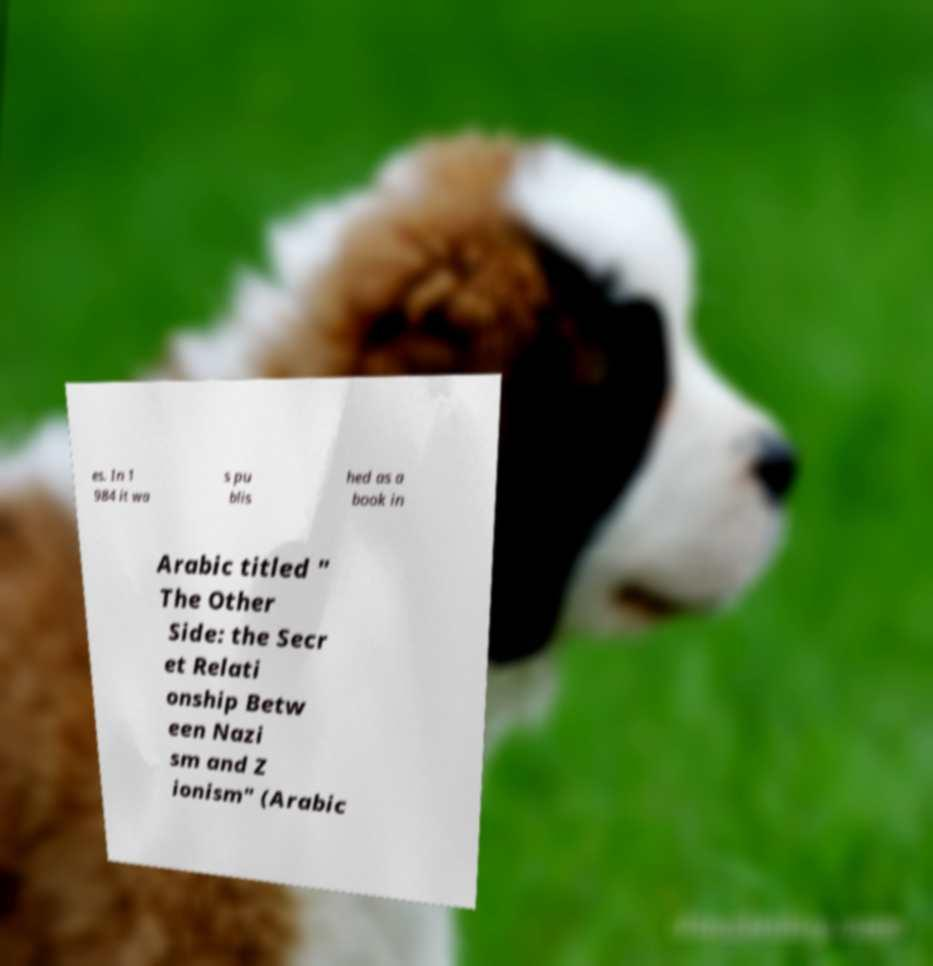What messages or text are displayed in this image? I need them in a readable, typed format. es. In 1 984 it wa s pu blis hed as a book in Arabic titled " The Other Side: the Secr et Relati onship Betw een Nazi sm and Z ionism" (Arabic 